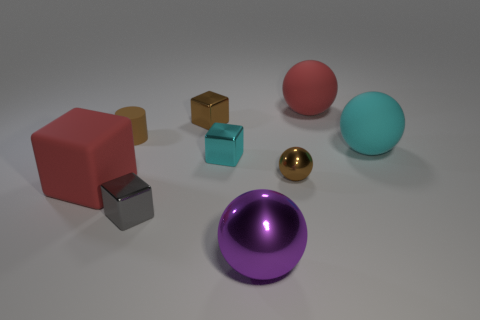How many other objects are there of the same material as the big cyan ball?
Your response must be concise. 3. What number of shiny objects are small gray blocks or yellow cubes?
Offer a terse response. 1. There is a red matte object that is behind the tiny sphere; does it have the same shape as the gray object?
Offer a very short reply. No. Is the number of things in front of the tiny rubber object greater than the number of tiny red balls?
Ensure brevity in your answer.  Yes. What number of brown things are both on the left side of the large purple ball and right of the small gray block?
Offer a terse response. 1. The small cube that is in front of the tiny brown object that is in front of the cyan sphere is what color?
Offer a very short reply. Gray. How many tiny shiny cubes are the same color as the cylinder?
Ensure brevity in your answer.  1. Do the big cube and the sphere behind the large cyan object have the same color?
Your response must be concise. Yes. Is the number of red things less than the number of spheres?
Your answer should be compact. Yes. Is the number of big red objects in front of the cyan rubber object greater than the number of tiny brown balls that are in front of the tiny gray cube?
Offer a terse response. Yes. 